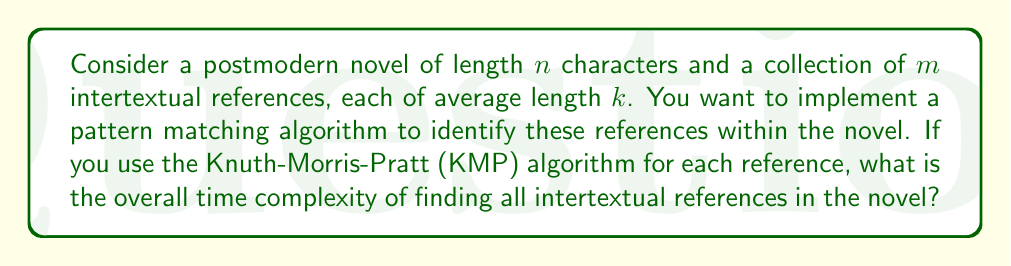Can you solve this math problem? To solve this problem, let's break it down step-by-step:

1. The Knuth-Morris-Pratt (KMP) algorithm is an efficient string matching algorithm with the following properties:
   - Preprocessing time: $O(k)$ for a pattern of length $k$
   - Matching time: $O(n)$ for a text of length $n$

2. In our case, we have:
   - A novel of length $n$
   - $m$ intertextual references
   - Each reference has an average length of $k$

3. For each intertextual reference:
   - Preprocessing time: $O(k)$
   - Matching time: $O(n)$

4. We need to perform this process for all $m$ references, so we multiply the above complexities by $m$:
   - Total preprocessing time: $O(m * k)$
   - Total matching time: $O(m * n)$

5. The overall time complexity is the sum of preprocessing and matching times:
   $O(m * k + m * n)$

6. We can factor out $m$:
   $O(m * (k + n))$

7. Since the novel length $n$ is typically much larger than the average reference length $k$, we can simplify this to:
   $O(m * n)$

This result reflects the postmodern nature of the text, where the interplay between multiple references ($m$) and the main text ($n$) creates a complex web of meanings, mirroring the computational complexity of identifying these connections.
Answer: $O(m * n)$, where $m$ is the number of intertextual references and $n$ is the length of the novel. 